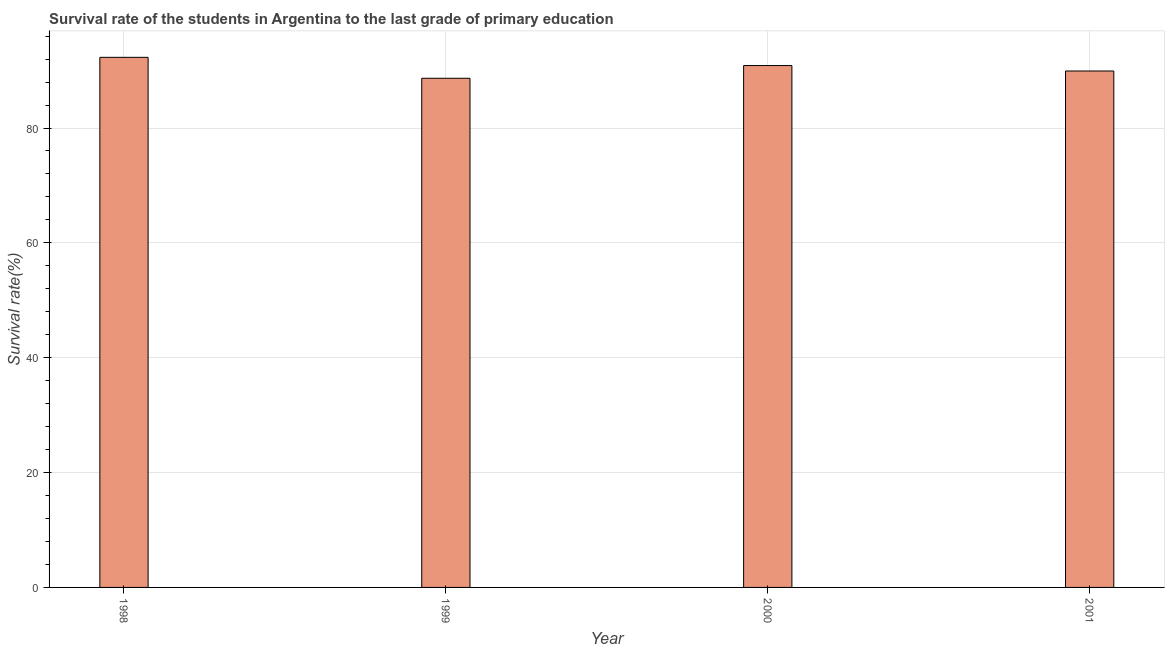What is the title of the graph?
Your answer should be very brief. Survival rate of the students in Argentina to the last grade of primary education. What is the label or title of the Y-axis?
Offer a terse response. Survival rate(%). What is the survival rate in primary education in 1998?
Give a very brief answer. 92.31. Across all years, what is the maximum survival rate in primary education?
Ensure brevity in your answer.  92.31. Across all years, what is the minimum survival rate in primary education?
Offer a terse response. 88.66. In which year was the survival rate in primary education minimum?
Your answer should be compact. 1999. What is the sum of the survival rate in primary education?
Provide a short and direct response. 361.79. What is the difference between the survival rate in primary education in 1999 and 2000?
Provide a short and direct response. -2.21. What is the average survival rate in primary education per year?
Provide a short and direct response. 90.45. What is the median survival rate in primary education?
Your answer should be very brief. 90.41. In how many years, is the survival rate in primary education greater than 16 %?
Your response must be concise. 4. Do a majority of the years between 1999 and 2000 (inclusive) have survival rate in primary education greater than 24 %?
Offer a terse response. Yes. Is the survival rate in primary education in 1998 less than that in 2000?
Your answer should be compact. No. What is the difference between the highest and the second highest survival rate in primary education?
Provide a short and direct response. 1.43. Is the sum of the survival rate in primary education in 1999 and 2000 greater than the maximum survival rate in primary education across all years?
Make the answer very short. Yes. What is the difference between the highest and the lowest survival rate in primary education?
Ensure brevity in your answer.  3.65. In how many years, is the survival rate in primary education greater than the average survival rate in primary education taken over all years?
Give a very brief answer. 2. How many bars are there?
Provide a short and direct response. 4. Are all the bars in the graph horizontal?
Make the answer very short. No. How many years are there in the graph?
Offer a terse response. 4. What is the difference between two consecutive major ticks on the Y-axis?
Your answer should be very brief. 20. What is the Survival rate(%) of 1998?
Your answer should be compact. 92.31. What is the Survival rate(%) of 1999?
Offer a terse response. 88.66. What is the Survival rate(%) in 2000?
Provide a short and direct response. 90.88. What is the Survival rate(%) of 2001?
Make the answer very short. 89.93. What is the difference between the Survival rate(%) in 1998 and 1999?
Your answer should be very brief. 3.65. What is the difference between the Survival rate(%) in 1998 and 2000?
Offer a terse response. 1.43. What is the difference between the Survival rate(%) in 1998 and 2001?
Offer a terse response. 2.38. What is the difference between the Survival rate(%) in 1999 and 2000?
Offer a very short reply. -2.21. What is the difference between the Survival rate(%) in 1999 and 2001?
Your response must be concise. -1.27. What is the difference between the Survival rate(%) in 2000 and 2001?
Your answer should be compact. 0.95. What is the ratio of the Survival rate(%) in 1998 to that in 1999?
Your answer should be very brief. 1.04. What is the ratio of the Survival rate(%) in 1998 to that in 2001?
Give a very brief answer. 1.03. What is the ratio of the Survival rate(%) in 1999 to that in 2000?
Give a very brief answer. 0.98. 